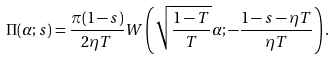<formula> <loc_0><loc_0><loc_500><loc_500>\Pi ( \alpha ; s ) = \frac { \pi ( 1 - s ) } { 2 \eta T } W \left ( \sqrt { \frac { 1 - T } { T } } \alpha ; - \frac { 1 - s - \eta T } { \eta T } \right ) .</formula> 